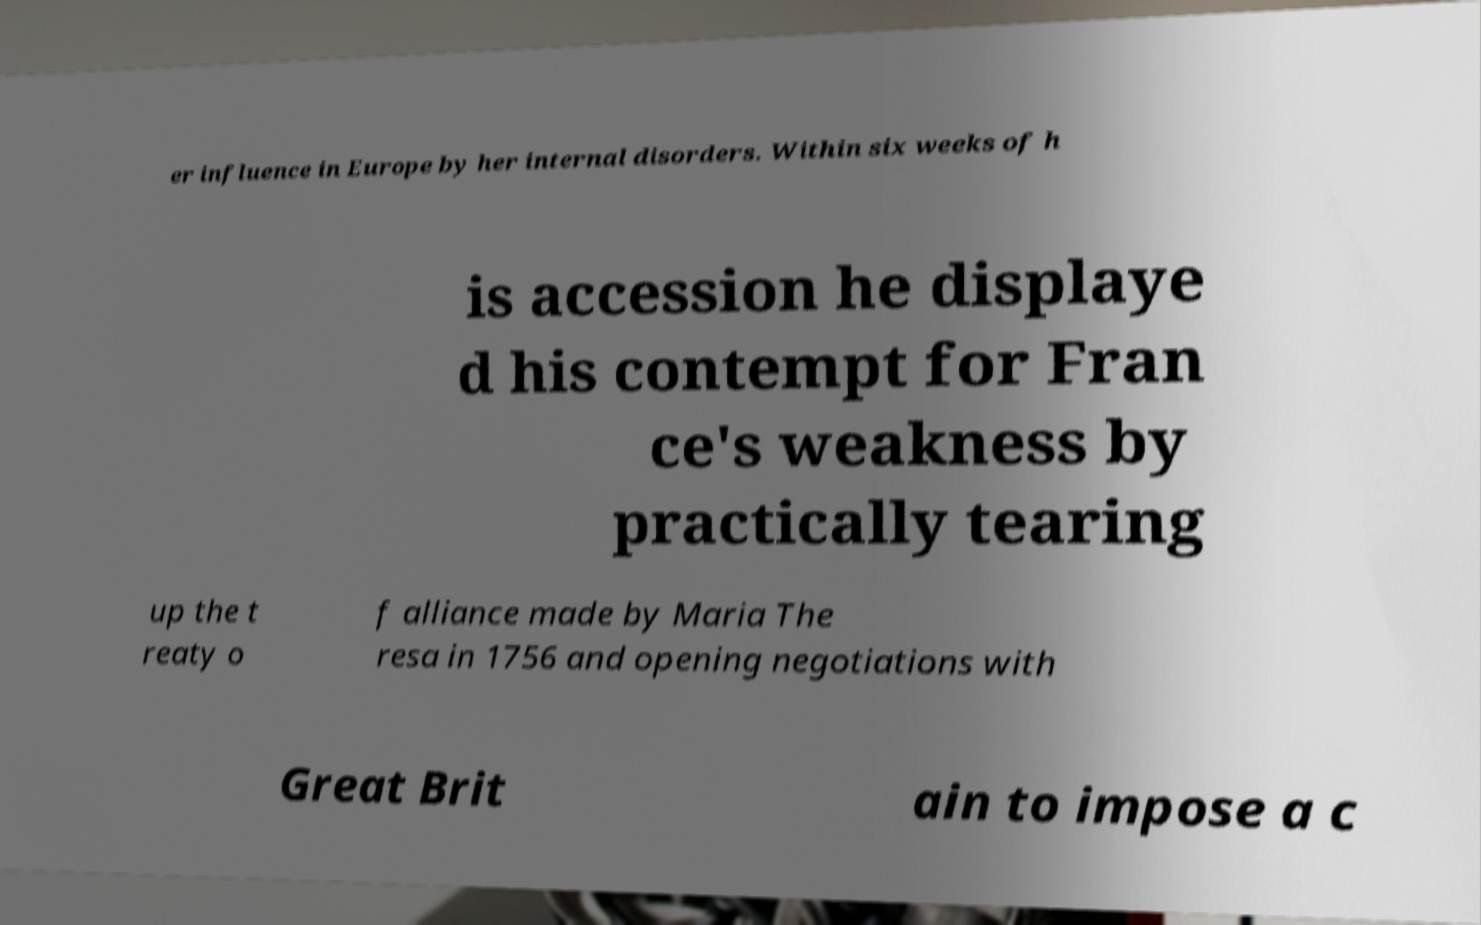What messages or text are displayed in this image? I need them in a readable, typed format. er influence in Europe by her internal disorders. Within six weeks of h is accession he displaye d his contempt for Fran ce's weakness by practically tearing up the t reaty o f alliance made by Maria The resa in 1756 and opening negotiations with Great Brit ain to impose a c 